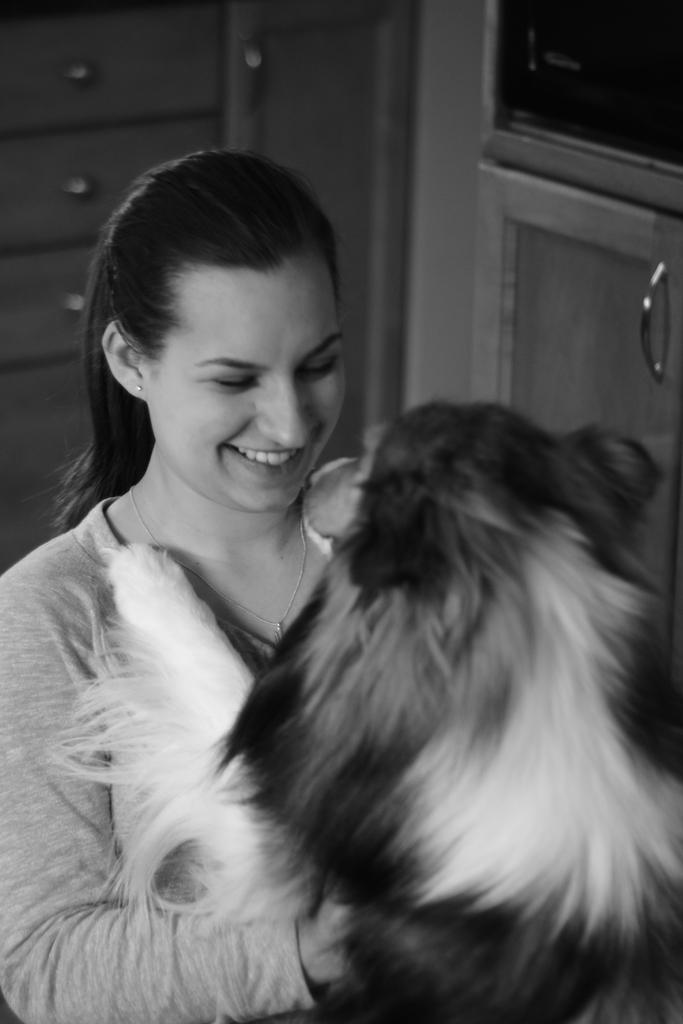Could you give a brief overview of what you see in this image? There is a woman holding a dog in front of her. 